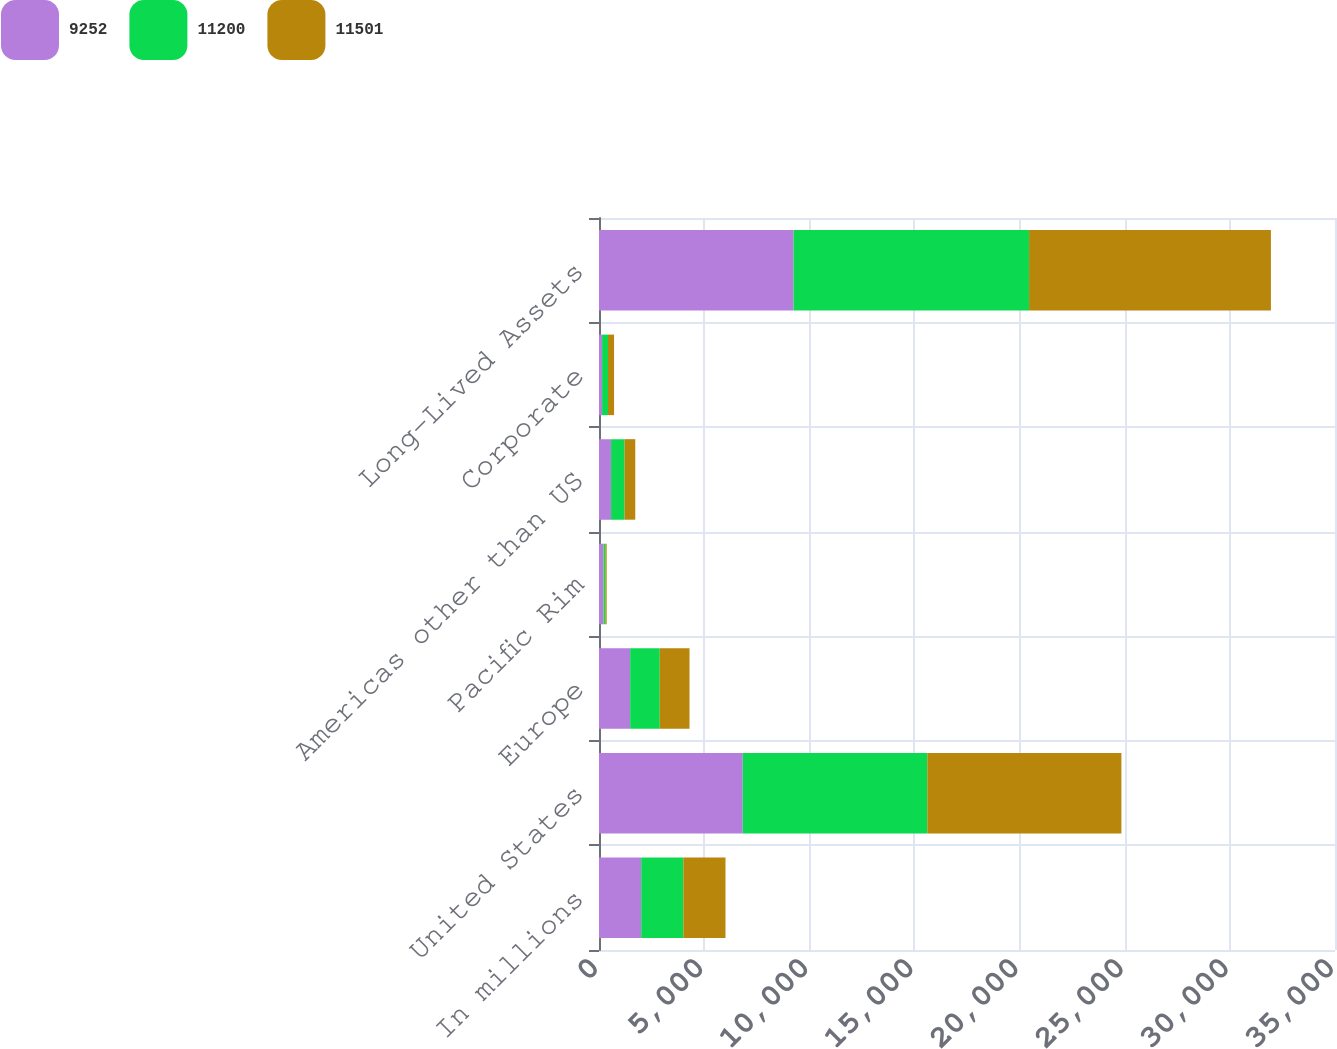Convert chart to OTSL. <chart><loc_0><loc_0><loc_500><loc_500><stacked_bar_chart><ecel><fcel>In millions<fcel>United States<fcel>Europe<fcel>Pacific Rim<fcel>Americas other than US<fcel>Corporate<fcel>Long-Lived Assets<nl><fcel>9252<fcel>2006<fcel>6837<fcel>1481<fcel>214<fcel>574<fcel>146<fcel>9252<nl><fcel>11200<fcel>2005<fcel>8776<fcel>1408<fcel>90<fcel>644<fcel>282<fcel>11200<nl><fcel>11501<fcel>2004<fcel>9229<fcel>1416<fcel>61<fcel>507<fcel>288<fcel>11501<nl></chart> 